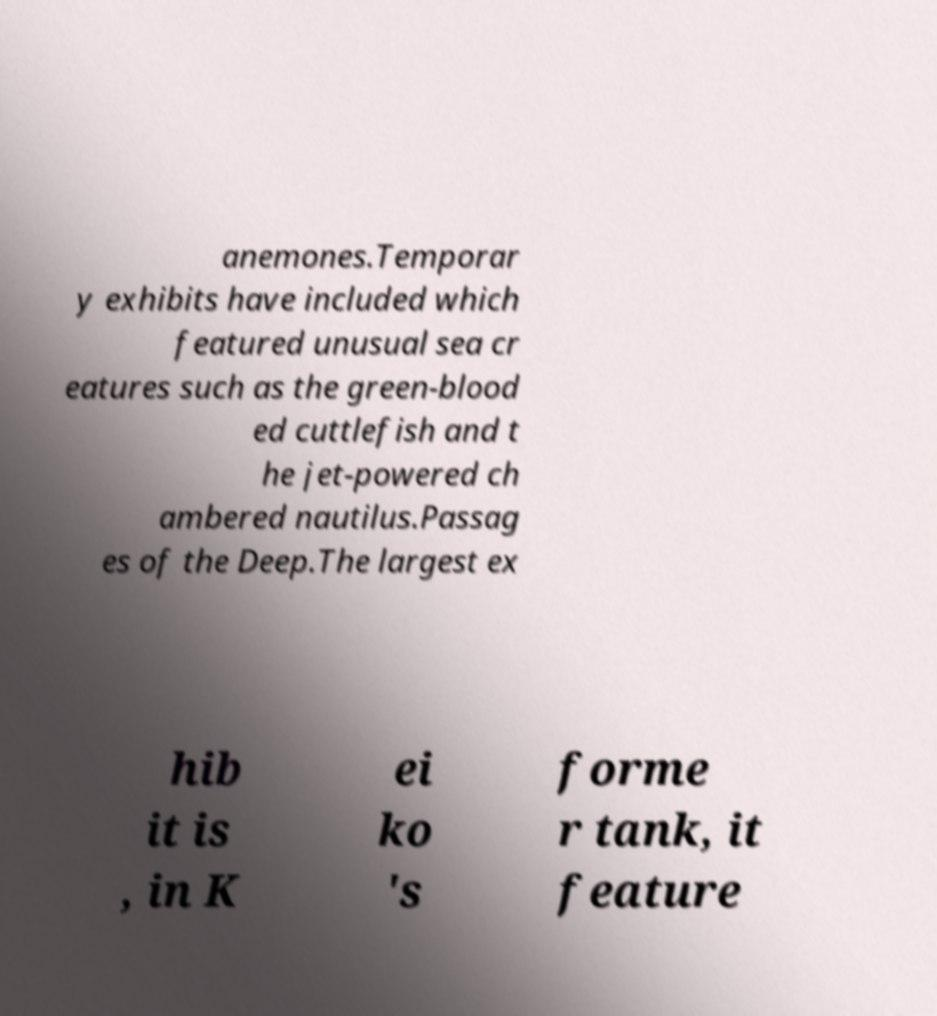Can you read and provide the text displayed in the image?This photo seems to have some interesting text. Can you extract and type it out for me? anemones.Temporar y exhibits have included which featured unusual sea cr eatures such as the green-blood ed cuttlefish and t he jet-powered ch ambered nautilus.Passag es of the Deep.The largest ex hib it is , in K ei ko 's forme r tank, it feature 